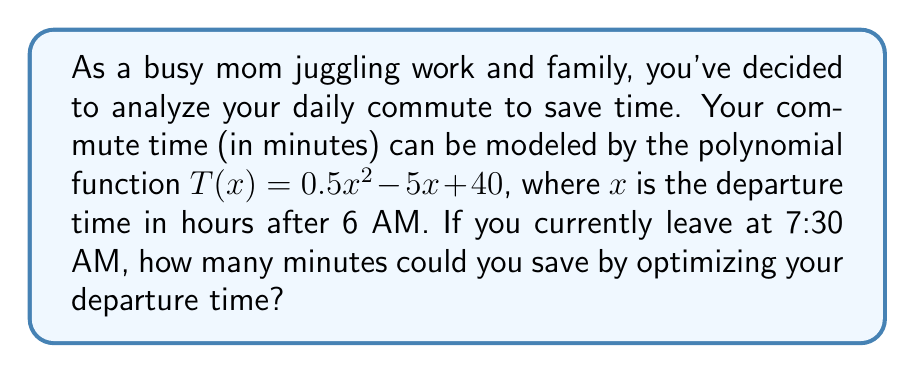Give your solution to this math problem. 1. First, let's find the current commute time:
   - 7:30 AM is 1.5 hours after 6 AM, so $x = 1.5$
   - $T(1.5) = 0.5(1.5)^2 - 5(1.5) + 40$
   - $T(1.5) = 0.5(2.25) - 7.5 + 40 = 33.625$ minutes

2. To find the optimal departure time, we need to find the minimum of the function:
   - The minimum occurs at the vertex of the parabola
   - For a quadratic function $ax^2 + bx + c$, the x-coordinate of the vertex is $-b/(2a)$
   - In our case, $a = 0.5$, $b = -5$
   - Optimal $x = -(-5)/(2(0.5)) = 5$ hours after 6 AM, or 11 AM

3. Calculate the commute time at the optimal departure time:
   - $T(5) = 0.5(5)^2 - 5(5) + 40$
   - $T(5) = 12.5 - 25 + 40 = 27.5$ minutes

4. Calculate the time saved:
   - Time saved = Current time - Optimal time
   - Time saved = $33.625 - 27.5 = 6.125$ minutes
Answer: 6.125 minutes 